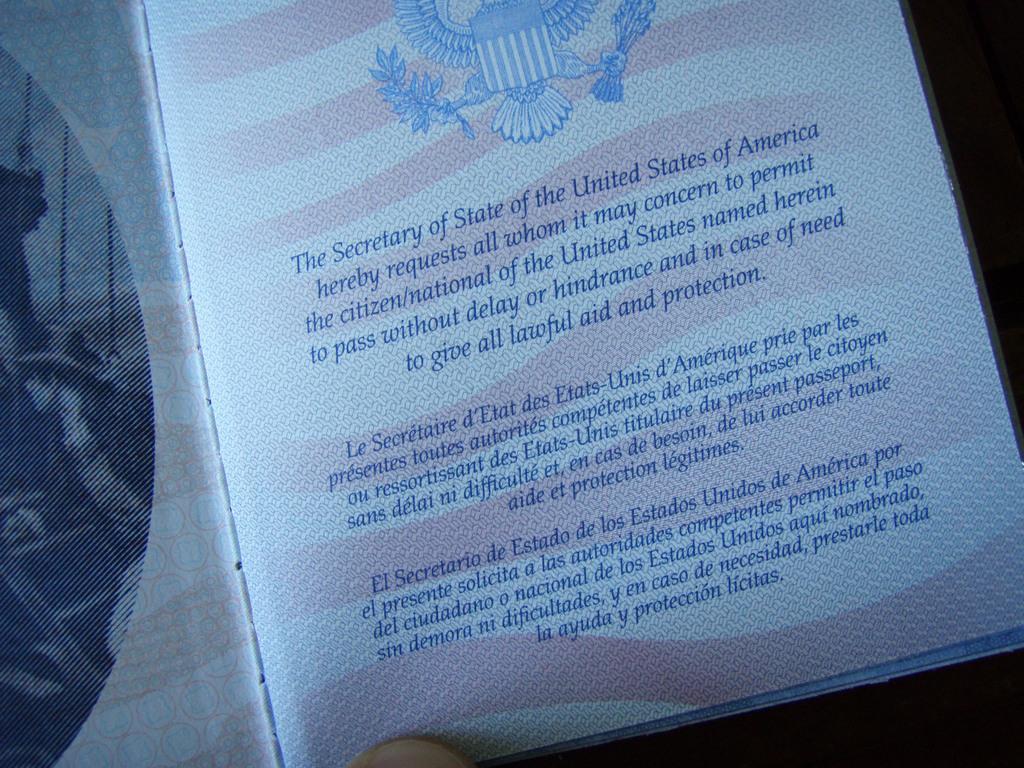Please provide a concise description of this image. In this picture we can see a book and on the book it is written in blue color. 